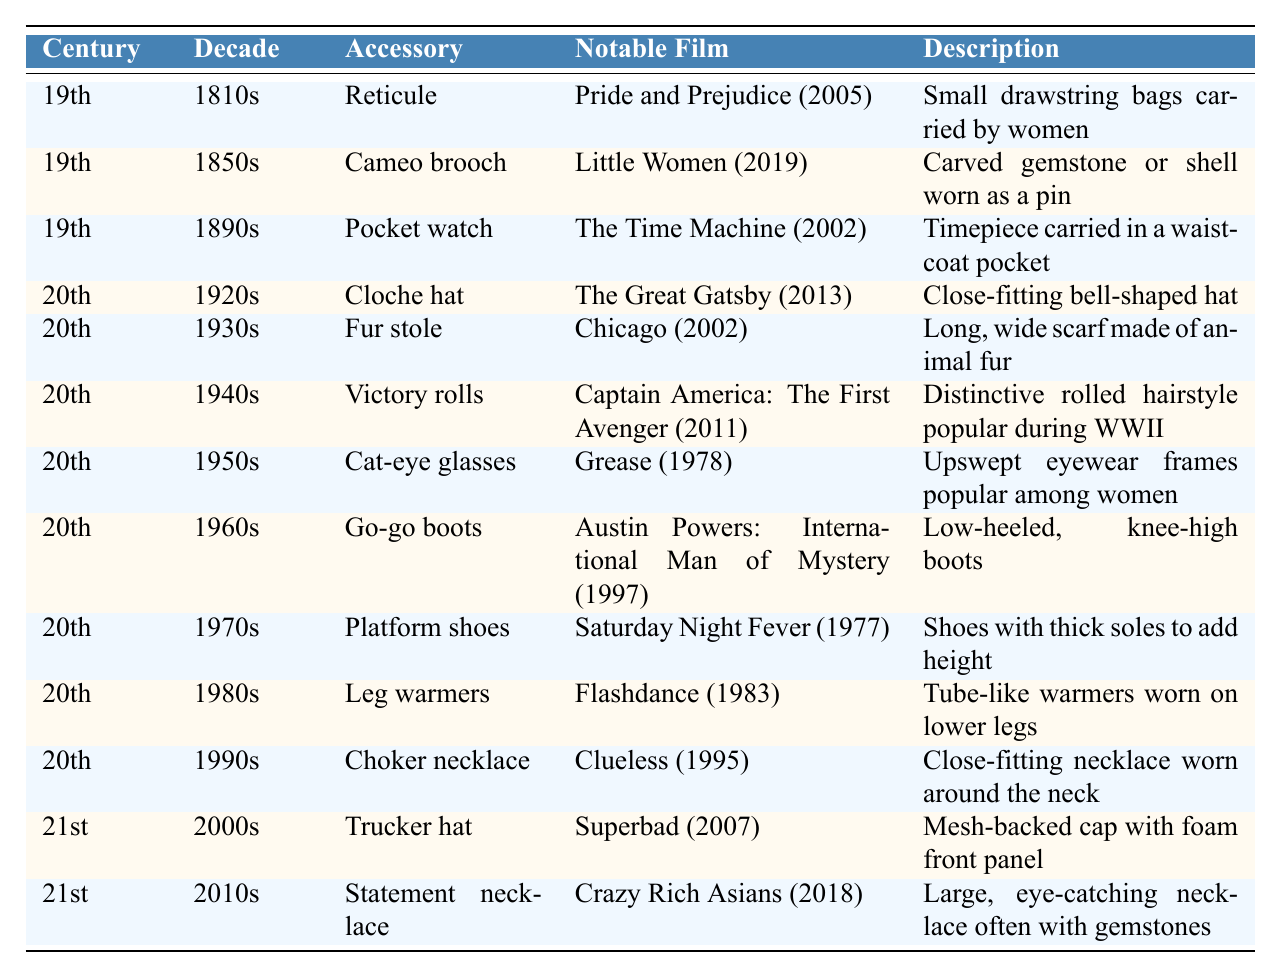What accessory is noted in the 1810s? The table shows that the accessory for the 1810s is the Reticule.
Answer: Reticule Which film features a Cameo brooch? The table indicates that the film featuring a Cameo brooch is Little Women (2019).
Answer: Little Women (2019) In which decade was the Cloche hat popular? According to the table, the Cloche hat was popular in the 1920s.
Answer: 1920s How many accessories are listed for the 20th century? There are a total of 11 entries for the 20th century accessories from the table.
Answer: 11 Is there an accessory from the 19th century associated with the film The Time Machine? The table confirms that there is an accessory from the 19th century, specifically a Pocket watch, featured in The Time Machine (2002).
Answer: Yes What is the description of the accessory in the 1950s? The table describes Cat-eye glasses in the 1950s as upswept eyewear frames popular among women.
Answer: Upswept eyewear frames popular among women Which decade features both a Trucker hat and a Statement necklace? The table indicates the Trucker hat is from the 2000s and the Statement necklace is from the 2010s, thus they are from different decades.
Answer: No What is the difference between the years of the first listed accessory and the last listed accessory? The first accessory, Reticule, is from 1810s and the last, Statement necklace, is from 2010s. The difference is 2010 - 1810 = 200.
Answer: 200 What decade has a description mentioning "distinctive rolled hairstyle"? The table shows that the decade with the description mentioning "distinctive rolled hairstyle" is the 1940s, referring to the Victory rolls.
Answer: 1940s Which two accessories were notable in the 20th century? From the table, two accessories from the 20th century include the Fur stole in the 1930s and Go-go boots in the 1960s.
Answer: Fur stole and Go-go boots How many total centuries are represented in the table? The table includes accessories from the 19th, 20th, and 21st centuries, which totals 3 different centuries.
Answer: 3 